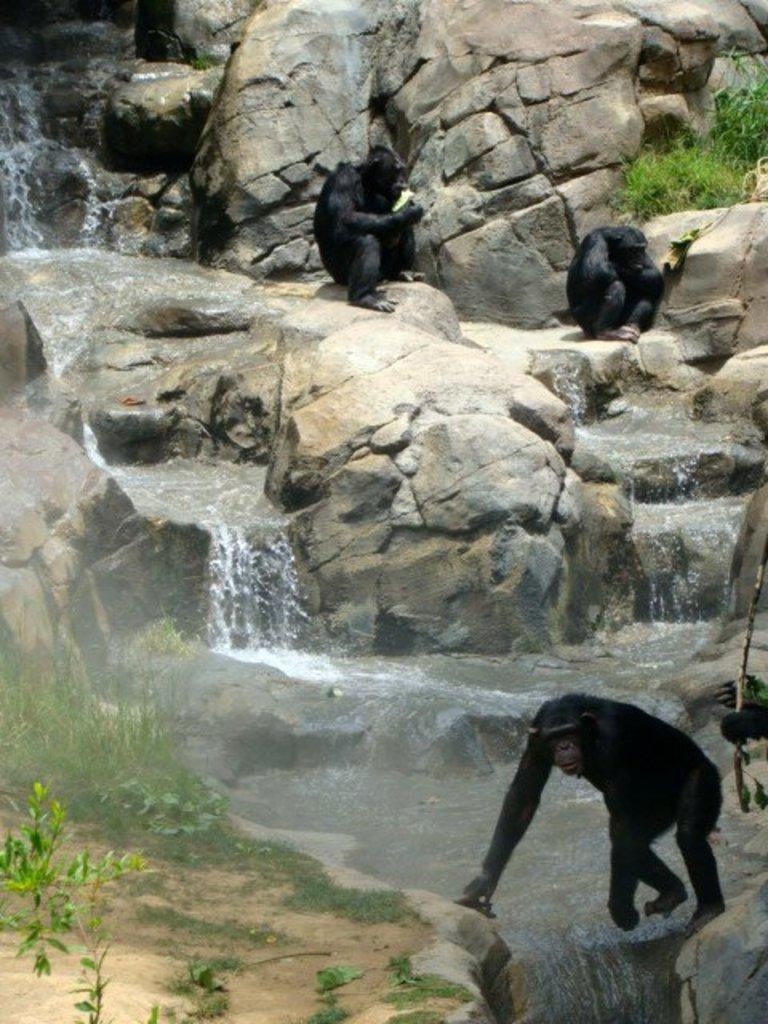What geographical feature is the main subject of the image? There is a mountain in the image. What natural feature is present near the mountain? A river is flowing in the image. Are there any animals visible in the image? Yes, three monkeys are sitting on the mountain. What type of vegetation can be seen on the left side of the image? There are plants on the left side of the image. How many trucks are parked near the coast in the image? There is no coast or trucks present in the image. What type of hope can be seen in the image? The concept of hope is not a tangible object that can be seen in the image. 